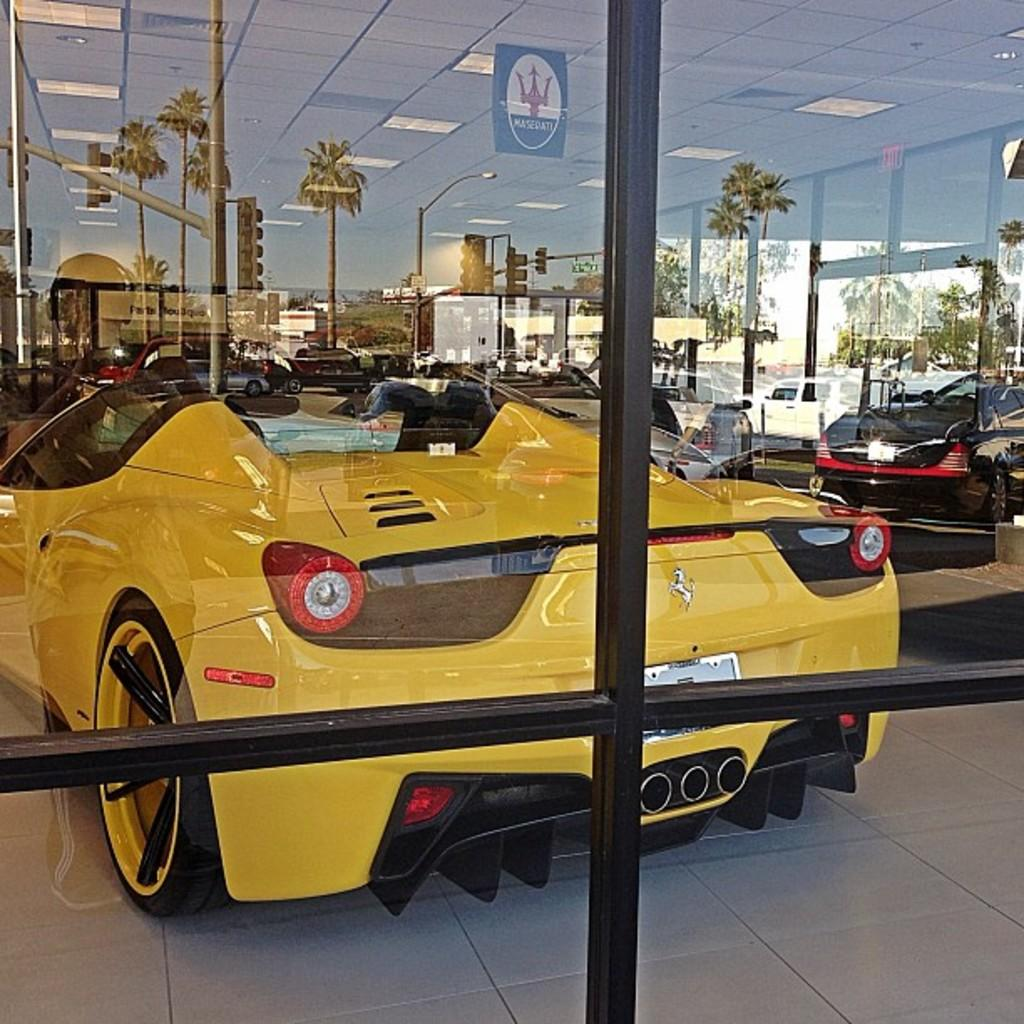What type of vehicles can be seen in the image? There are cars in the image. What else is present in the image besides cars? There are lights visible in the image. What can be seen in the mirror reflection in the image? In the mirror reflection, there are trees, poles, traffic lights, and buildings visible. Where are the dolls and the baby playing in the alley in the image? There are no dolls, baby, or alley present in the image. 